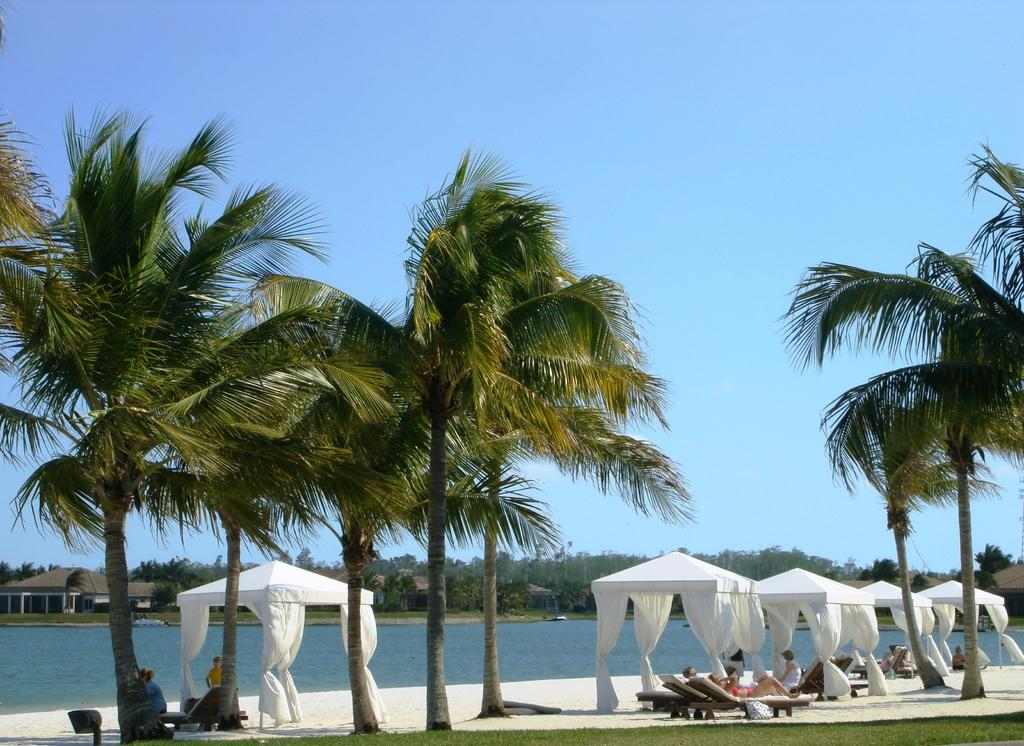What type of natural environment is depicted in the image? The image features many trees and a sea, indicating a coastal or forested area. Can you describe the people in the image? There are people sleeping on chairs in the image. What is the primary feature of the landscape in the image? The sea is the primary feature of the landscape in the image. What type of blade can be seen cutting through the mountain in the image? There is no mountain or blade present in the image; it features trees, a sea, and people sleeping on chairs. 